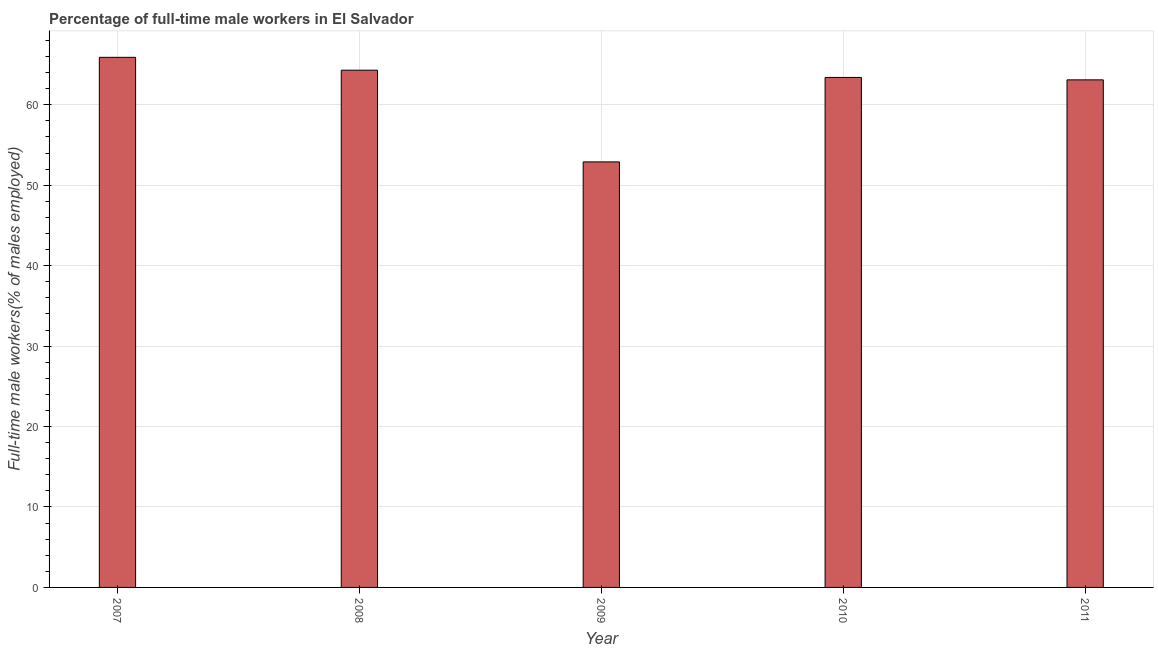Does the graph contain any zero values?
Make the answer very short. No. What is the title of the graph?
Your response must be concise. Percentage of full-time male workers in El Salvador. What is the label or title of the Y-axis?
Ensure brevity in your answer.  Full-time male workers(% of males employed). What is the percentage of full-time male workers in 2011?
Your answer should be very brief. 63.1. Across all years, what is the maximum percentage of full-time male workers?
Make the answer very short. 65.9. Across all years, what is the minimum percentage of full-time male workers?
Make the answer very short. 52.9. What is the sum of the percentage of full-time male workers?
Your answer should be compact. 309.6. What is the difference between the percentage of full-time male workers in 2008 and 2011?
Your response must be concise. 1.2. What is the average percentage of full-time male workers per year?
Offer a very short reply. 61.92. What is the median percentage of full-time male workers?
Ensure brevity in your answer.  63.4. What is the ratio of the percentage of full-time male workers in 2008 to that in 2009?
Keep it short and to the point. 1.22. Is the difference between the percentage of full-time male workers in 2007 and 2010 greater than the difference between any two years?
Give a very brief answer. No. Is the sum of the percentage of full-time male workers in 2009 and 2010 greater than the maximum percentage of full-time male workers across all years?
Provide a succinct answer. Yes. What is the difference between the highest and the lowest percentage of full-time male workers?
Make the answer very short. 13. How many bars are there?
Provide a short and direct response. 5. Are all the bars in the graph horizontal?
Provide a succinct answer. No. What is the difference between two consecutive major ticks on the Y-axis?
Offer a very short reply. 10. Are the values on the major ticks of Y-axis written in scientific E-notation?
Offer a terse response. No. What is the Full-time male workers(% of males employed) in 2007?
Make the answer very short. 65.9. What is the Full-time male workers(% of males employed) in 2008?
Give a very brief answer. 64.3. What is the Full-time male workers(% of males employed) of 2009?
Your answer should be very brief. 52.9. What is the Full-time male workers(% of males employed) of 2010?
Keep it short and to the point. 63.4. What is the Full-time male workers(% of males employed) of 2011?
Provide a succinct answer. 63.1. What is the difference between the Full-time male workers(% of males employed) in 2007 and 2008?
Offer a terse response. 1.6. What is the difference between the Full-time male workers(% of males employed) in 2007 and 2009?
Offer a terse response. 13. What is the difference between the Full-time male workers(% of males employed) in 2007 and 2011?
Make the answer very short. 2.8. What is the difference between the Full-time male workers(% of males employed) in 2008 and 2010?
Provide a succinct answer. 0.9. What is the difference between the Full-time male workers(% of males employed) in 2008 and 2011?
Your response must be concise. 1.2. What is the difference between the Full-time male workers(% of males employed) in 2009 and 2010?
Provide a short and direct response. -10.5. What is the ratio of the Full-time male workers(% of males employed) in 2007 to that in 2009?
Give a very brief answer. 1.25. What is the ratio of the Full-time male workers(% of males employed) in 2007 to that in 2010?
Your response must be concise. 1.04. What is the ratio of the Full-time male workers(% of males employed) in 2007 to that in 2011?
Provide a short and direct response. 1.04. What is the ratio of the Full-time male workers(% of males employed) in 2008 to that in 2009?
Offer a terse response. 1.22. What is the ratio of the Full-time male workers(% of males employed) in 2009 to that in 2010?
Provide a succinct answer. 0.83. What is the ratio of the Full-time male workers(% of males employed) in 2009 to that in 2011?
Offer a very short reply. 0.84. What is the ratio of the Full-time male workers(% of males employed) in 2010 to that in 2011?
Offer a very short reply. 1. 